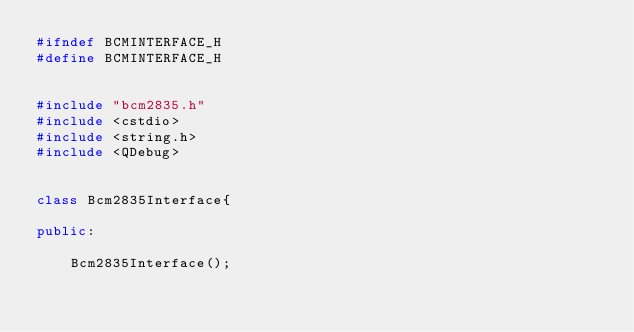Convert code to text. <code><loc_0><loc_0><loc_500><loc_500><_C++_>#ifndef BCMINTERFACE_H
#define BCMINTERFACE_H


#include "bcm2835.h"
#include <cstdio>
#include <string.h>
#include <QDebug>


class Bcm2835Interface{

public:

    Bcm2835Interface();</code> 